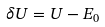<formula> <loc_0><loc_0><loc_500><loc_500>\delta U = U - E _ { 0 }</formula> 